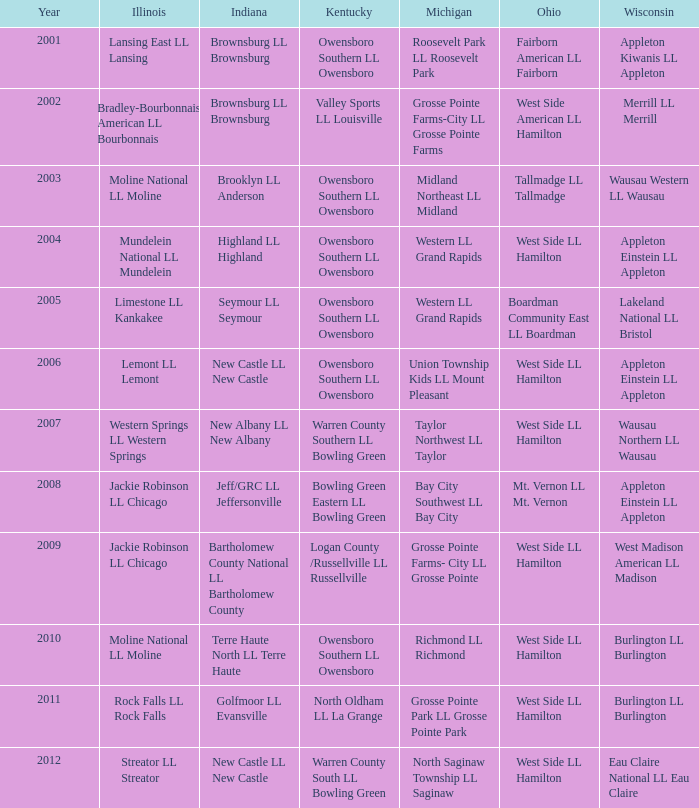What was the little league team from Indiana when the little league team from Michigan was Midland Northeast LL Midland? Brooklyn LL Anderson. 